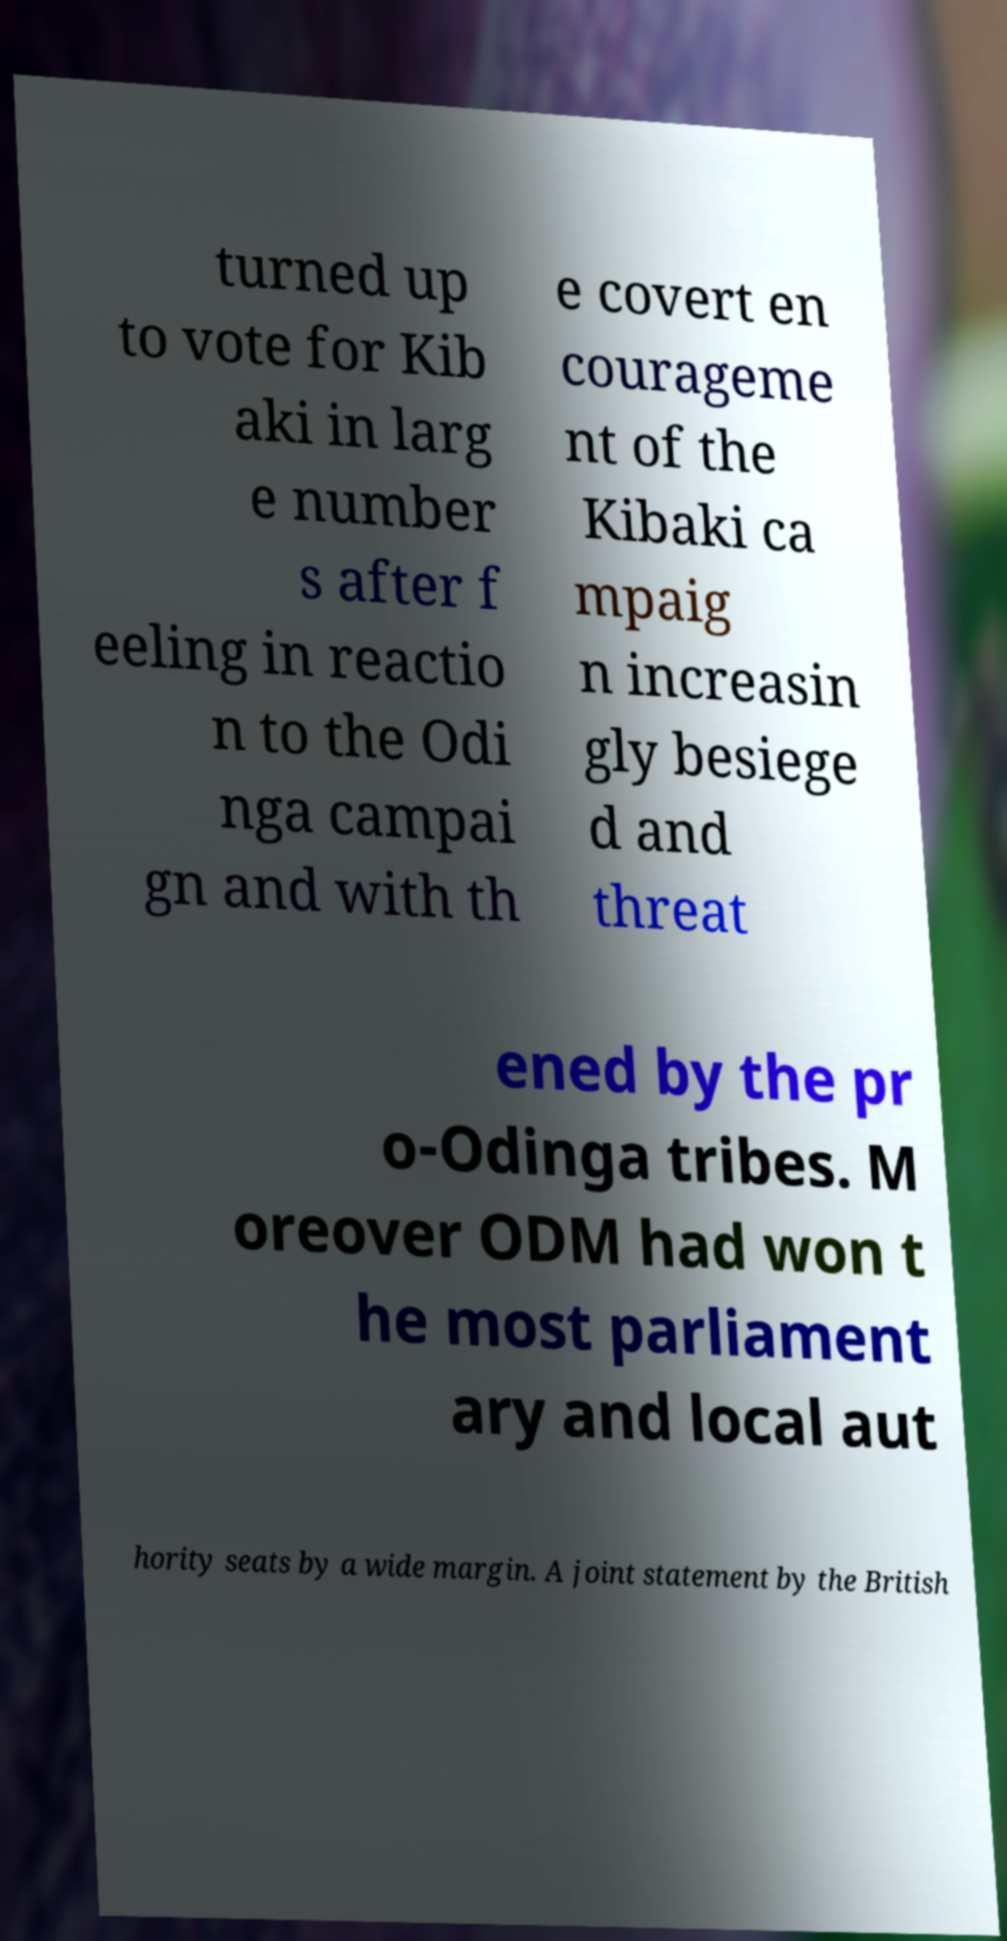Please identify and transcribe the text found in this image. turned up to vote for Kib aki in larg e number s after f eeling in reactio n to the Odi nga campai gn and with th e covert en courageme nt of the Kibaki ca mpaig n increasin gly besiege d and threat ened by the pr o-Odinga tribes. M oreover ODM had won t he most parliament ary and local aut hority seats by a wide margin. A joint statement by the British 